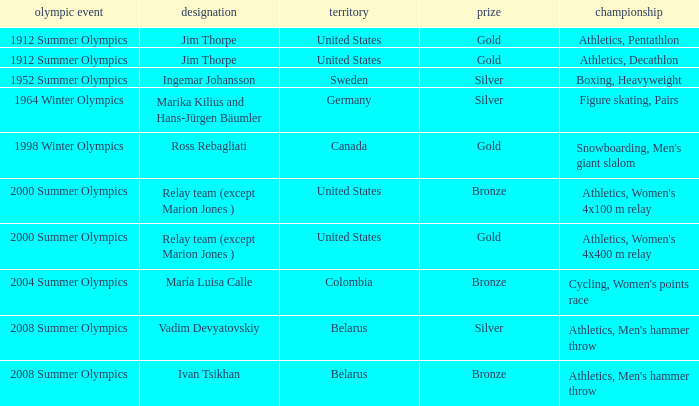Which country in the 2008 summer olympics is vadim devyatovskiy from? Belarus. 